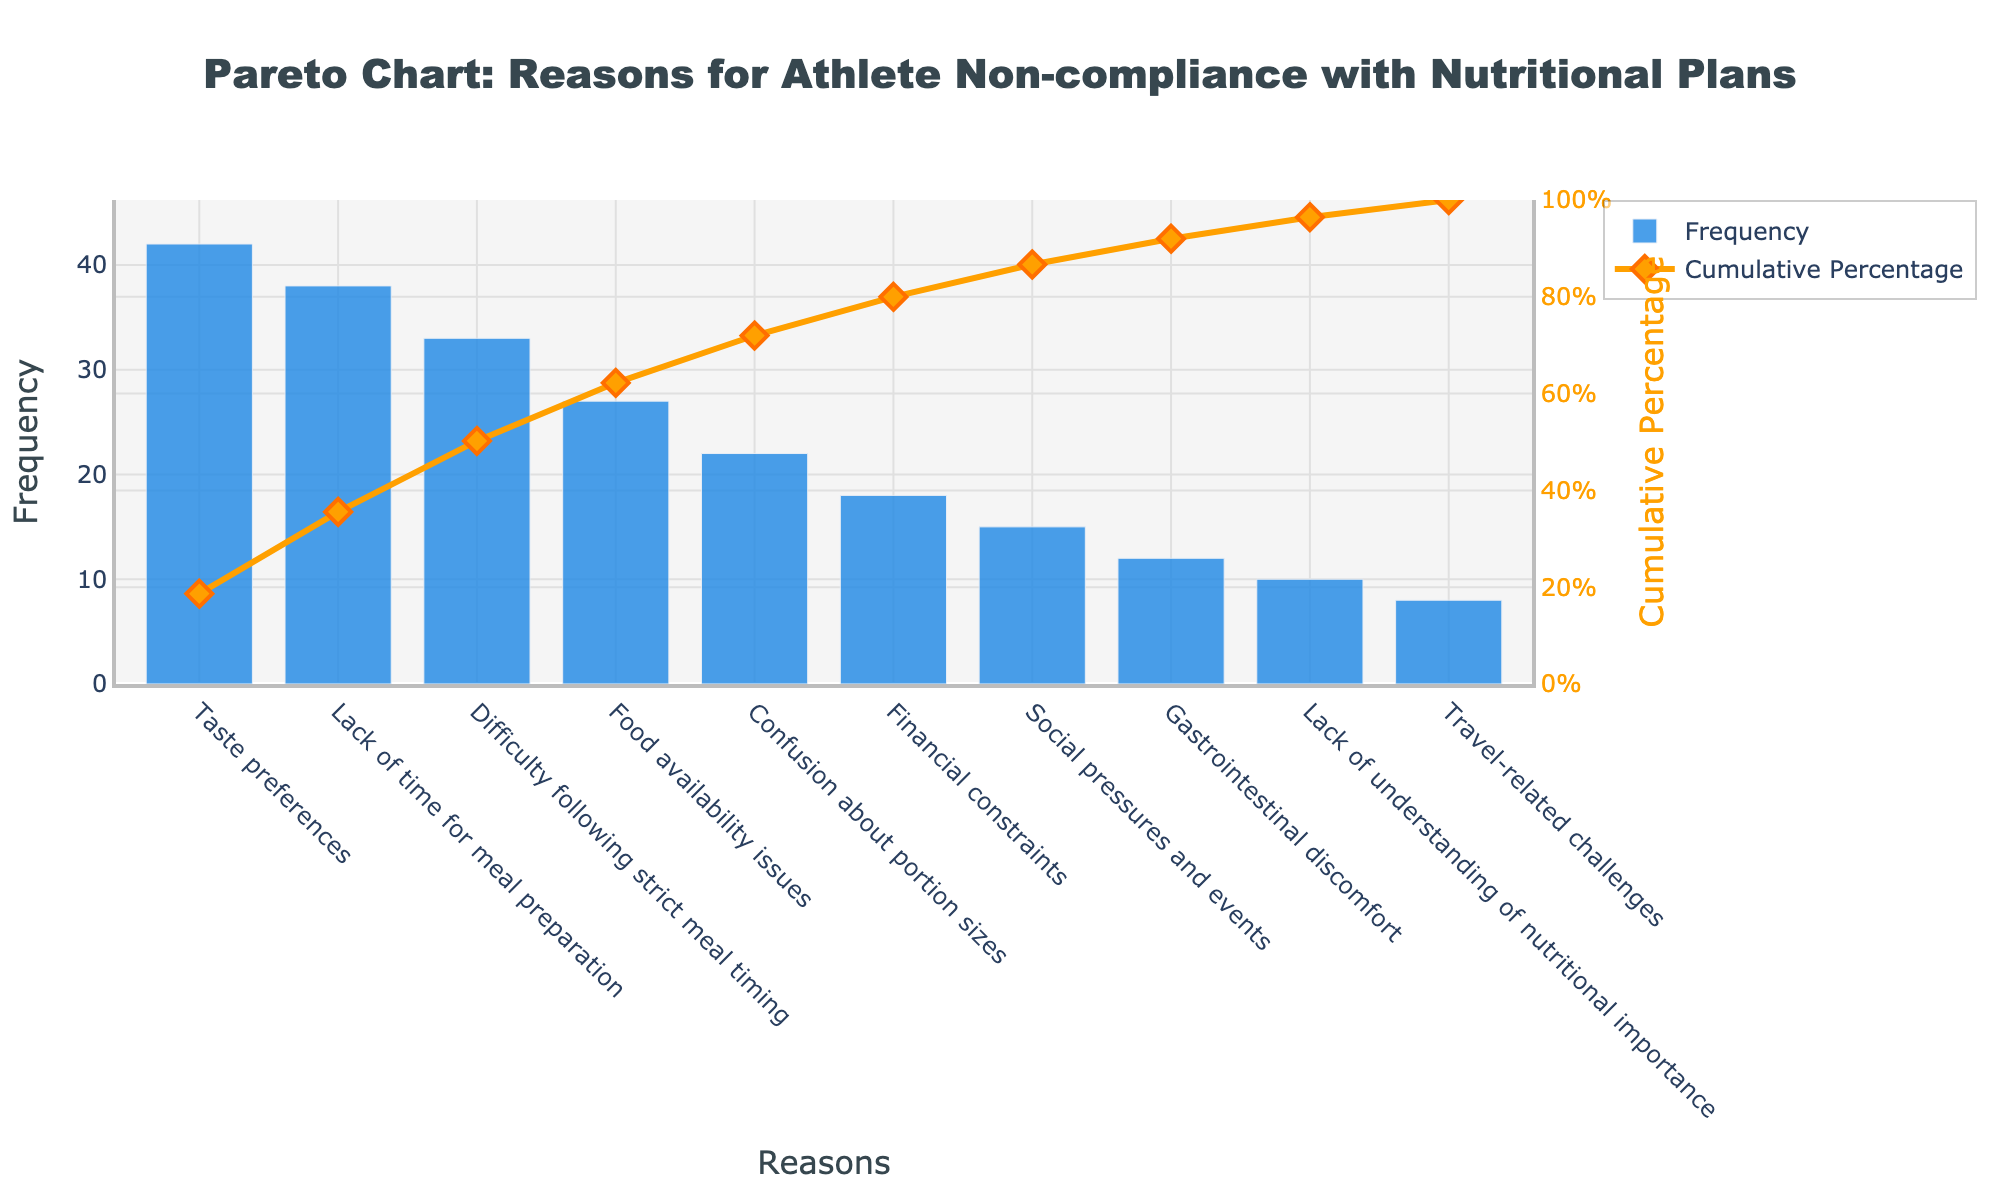What is the most common reason for athlete non-compliance with nutritional plans? The most common reason appears as the highest bar on the chart, which is 'Taste preferences'. This means it has the highest frequency.
Answer: Taste preferences Which reason has the lowest frequency? The bar with the smallest height represents the reason with the lowest frequency, which is 'Travel-related challenges'.
Answer: Travel-related challenges What is the cumulative percentage for 'Confusion about portion sizes'? Locate the 'Confusion about portion sizes' bar and follow the corresponding point on the cumulative percentage line. It reaches approximately 78%.
Answer: ~78% How many reasons have a frequency higher than 'Financial constraints'? Identify the 'Financial constraints' bar and count all bars that are taller. Those are 'Taste preferences', 'Lack of time for meal preparation', 'Difficulty following strict meal timing', 'Food availability issues', and 'Confusion about portion sizes'. Five bars are taller.
Answer: 5 What is the cumulative percentage after the second most frequent reason? After 'Taste preferences', the next bar is 'Lack of time for meal preparation'. Follow this bar up to the cumulative percentage line, which reaches approximately 53%.
Answer: ~53% What is the total frequency of the top three reasons? Identify the top three reasons ('Taste preferences', 'Lack of time for meal preparation', and 'Difficulty following strict meal timing') and sum their frequencies: 42 + 38 + 33 = 113.
Answer: 113 Which reason causes about one-third of the total non-compliance issues? The cumulative percentage showing approximately one-third, or about 33%, aligns with 'Difficulty following strict meal timing'.
Answer: Difficulty following strict meal timing How does 'Social pressures and events' compare in frequency to 'Gastrointestinal discomfort'? Compare the heights of the bars 'Social pressures and events' and 'Gastrointestinal discomfort'. 'Social pressures and events' has a higher frequency (15) compared to 'Gastrointestinal discomfort' (12).
Answer: Higher Between 'Lack of understanding of nutritional importance' and 'Travel-related challenges', which has a higher cumulative percentage impact? Compare the positions of the cumulative percentage line for 'Lack of understanding of nutritional importance' and 'Travel-related challenges'. 'Lack of understanding of nutritional importance' comes earlier, indicating a higher cumulative percentage impact.
Answer: Lack of understanding of nutritional importance 